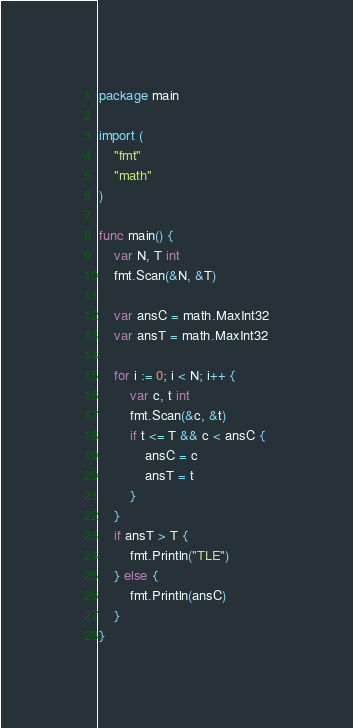<code> <loc_0><loc_0><loc_500><loc_500><_Go_>package main

import (
	"fmt"
	"math"
)

func main() {
	var N, T int
	fmt.Scan(&N, &T)

	var ansC = math.MaxInt32
	var ansT = math.MaxInt32

	for i := 0; i < N; i++ {
		var c, t int
		fmt.Scan(&c, &t)
		if t <= T && c < ansC {
			ansC = c
			ansT = t
		}
	}
	if ansT > T {
		fmt.Println("TLE")
	} else {
		fmt.Println(ansC)
	}
}
</code> 